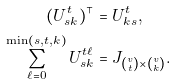<formula> <loc_0><loc_0><loc_500><loc_500>( U _ { s k } ^ { t } ) ^ { \top } & = U _ { k s } ^ { t } , \\ \sum _ { \ell = 0 } ^ { \min ( s , t , k ) } U _ { s k } ^ { t \ell } & = J _ { { v \choose t } \times { v \choose k } } .</formula> 